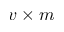Convert formula to latex. <formula><loc_0><loc_0><loc_500><loc_500>v \times m</formula> 